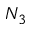Convert formula to latex. <formula><loc_0><loc_0><loc_500><loc_500>N _ { 3 }</formula> 